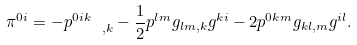Convert formula to latex. <formula><loc_0><loc_0><loc_500><loc_500>\pi ^ { 0 i } = - p ^ { 0 i k } _ { \quad , k } - \frac { 1 } { 2 } p ^ { l m } g _ { l m , k } g ^ { k i } - 2 p ^ { 0 k m } g _ { k l , m } g ^ { i l } .</formula> 